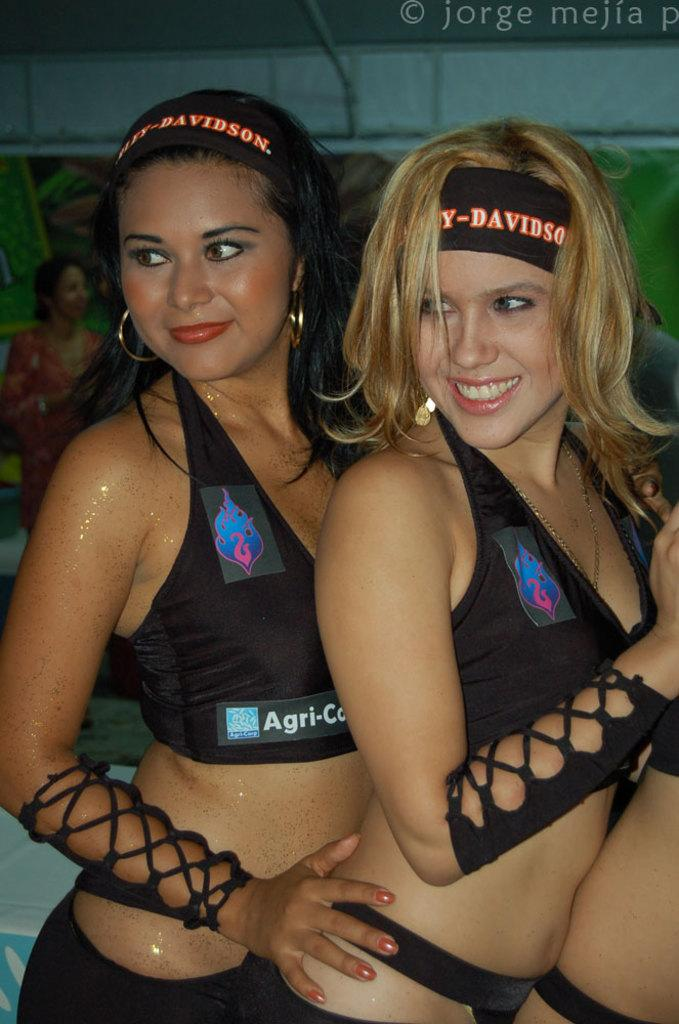<image>
Present a compact description of the photo's key features. A woman is wearing a hearband that says Harley Davidson on it. 